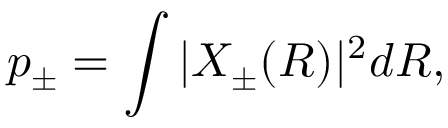Convert formula to latex. <formula><loc_0><loc_0><loc_500><loc_500>p _ { \pm } = \int | X _ { \pm } ( R ) | ^ { 2 } d R ,</formula> 